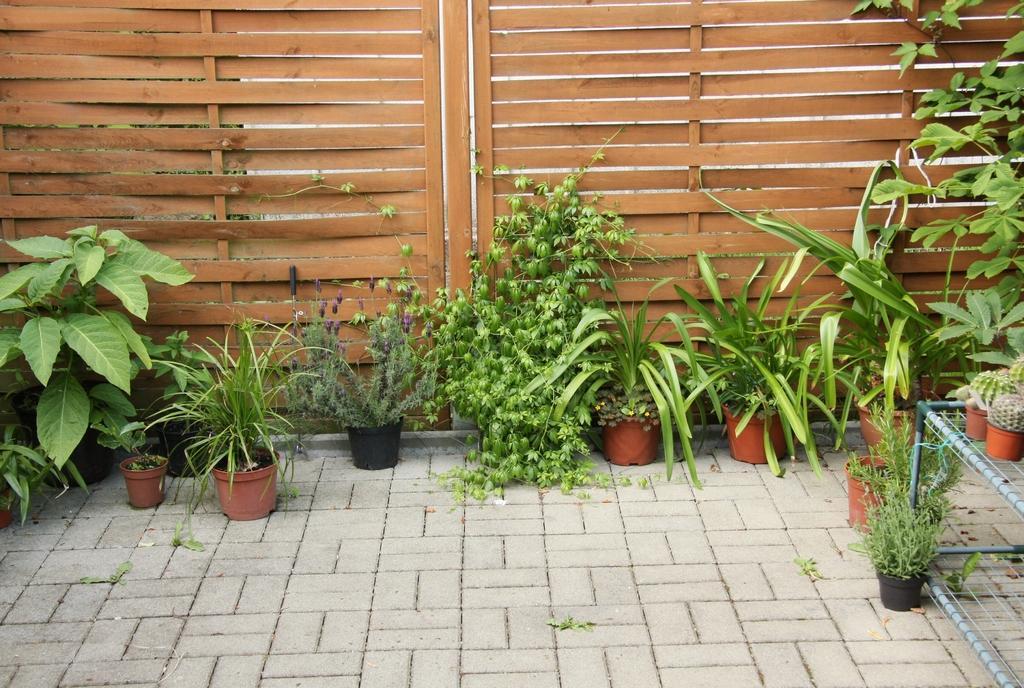Describe this image in one or two sentences. This picture is clicked outside. On the right there are some house plans placed on the top of the stand and we can see many number of houseplants placed on the pavement. In the background we can see the wooden gates. 